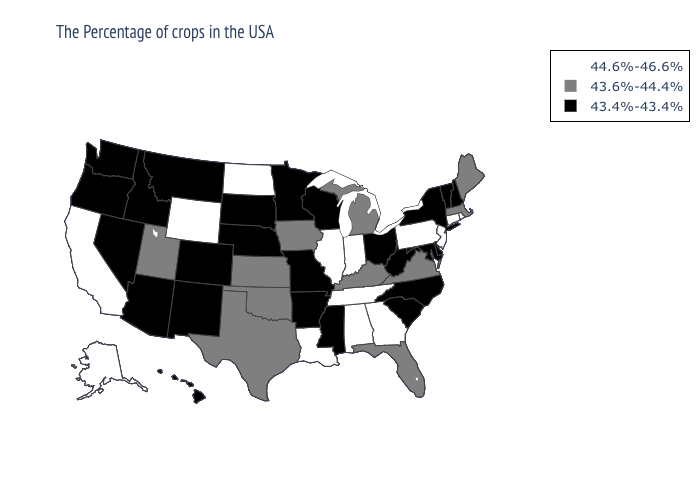Name the states that have a value in the range 44.6%-46.6%?
Concise answer only. Rhode Island, Connecticut, New Jersey, Pennsylvania, Georgia, Indiana, Alabama, Tennessee, Illinois, Louisiana, North Dakota, Wyoming, California, Alaska. What is the value of North Dakota?
Write a very short answer. 44.6%-46.6%. Name the states that have a value in the range 43.6%-44.4%?
Write a very short answer. Maine, Massachusetts, Virginia, Florida, Michigan, Kentucky, Iowa, Kansas, Oklahoma, Texas, Utah. Name the states that have a value in the range 43.6%-44.4%?
Be succinct. Maine, Massachusetts, Virginia, Florida, Michigan, Kentucky, Iowa, Kansas, Oklahoma, Texas, Utah. Name the states that have a value in the range 44.6%-46.6%?
Give a very brief answer. Rhode Island, Connecticut, New Jersey, Pennsylvania, Georgia, Indiana, Alabama, Tennessee, Illinois, Louisiana, North Dakota, Wyoming, California, Alaska. Name the states that have a value in the range 43.4%-43.4%?
Quick response, please. New Hampshire, Vermont, New York, Delaware, Maryland, North Carolina, South Carolina, West Virginia, Ohio, Wisconsin, Mississippi, Missouri, Arkansas, Minnesota, Nebraska, South Dakota, Colorado, New Mexico, Montana, Arizona, Idaho, Nevada, Washington, Oregon, Hawaii. Name the states that have a value in the range 44.6%-46.6%?
Write a very short answer. Rhode Island, Connecticut, New Jersey, Pennsylvania, Georgia, Indiana, Alabama, Tennessee, Illinois, Louisiana, North Dakota, Wyoming, California, Alaska. Name the states that have a value in the range 44.6%-46.6%?
Quick response, please. Rhode Island, Connecticut, New Jersey, Pennsylvania, Georgia, Indiana, Alabama, Tennessee, Illinois, Louisiana, North Dakota, Wyoming, California, Alaska. Which states hav the highest value in the MidWest?
Be succinct. Indiana, Illinois, North Dakota. Among the states that border West Virginia , which have the highest value?
Concise answer only. Pennsylvania. Does Rhode Island have the highest value in the Northeast?
Quick response, please. Yes. Among the states that border Nebraska , does Kansas have the lowest value?
Short answer required. No. What is the value of Colorado?
Write a very short answer. 43.4%-43.4%. What is the highest value in states that border Massachusetts?
Answer briefly. 44.6%-46.6%. Does South Dakota have the lowest value in the MidWest?
Write a very short answer. Yes. 